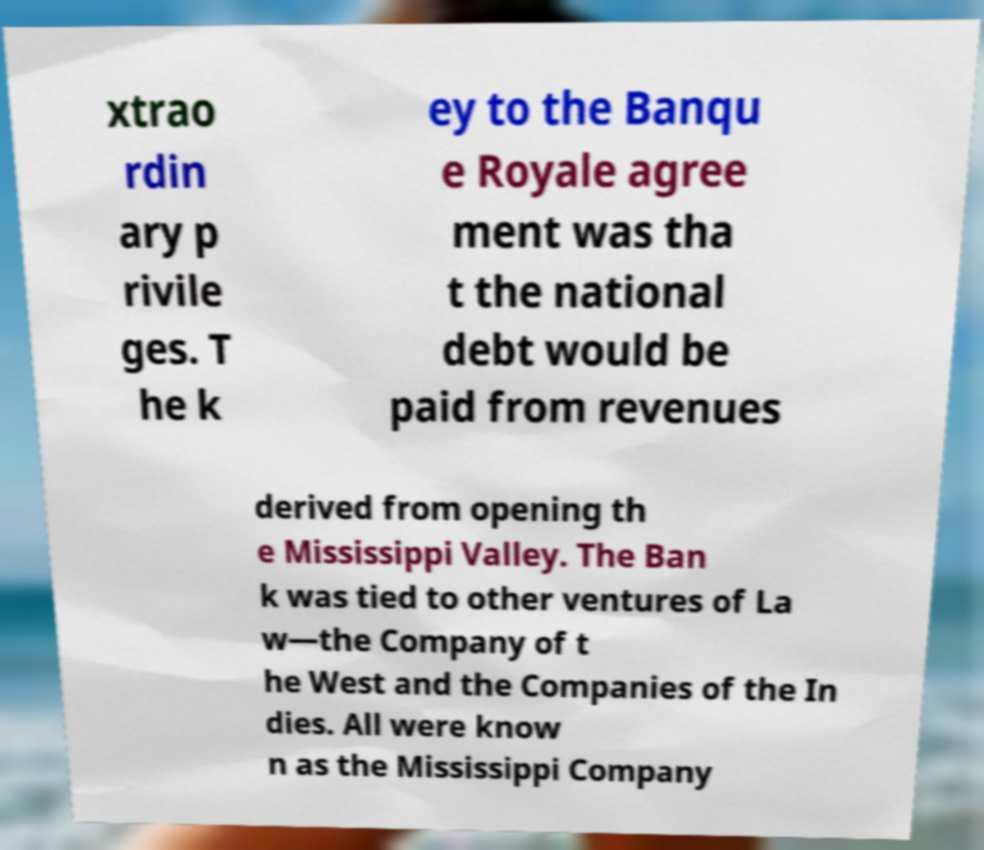Please read and relay the text visible in this image. What does it say? xtrao rdin ary p rivile ges. T he k ey to the Banqu e Royale agree ment was tha t the national debt would be paid from revenues derived from opening th e Mississippi Valley. The Ban k was tied to other ventures of La w—the Company of t he West and the Companies of the In dies. All were know n as the Mississippi Company 